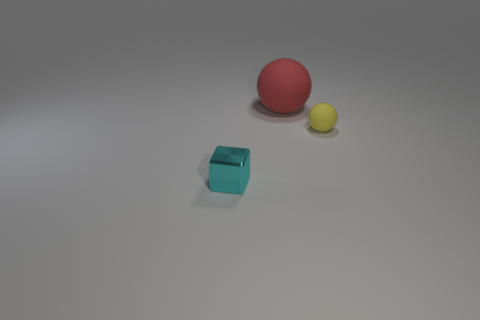Add 3 big red rubber cubes. How many objects exist? 6 Subtract all cubes. How many objects are left? 2 Subtract all tiny blocks. Subtract all cyan shiny blocks. How many objects are left? 1 Add 3 red matte spheres. How many red matte spheres are left? 4 Add 1 purple matte cylinders. How many purple matte cylinders exist? 1 Subtract 0 cyan spheres. How many objects are left? 3 